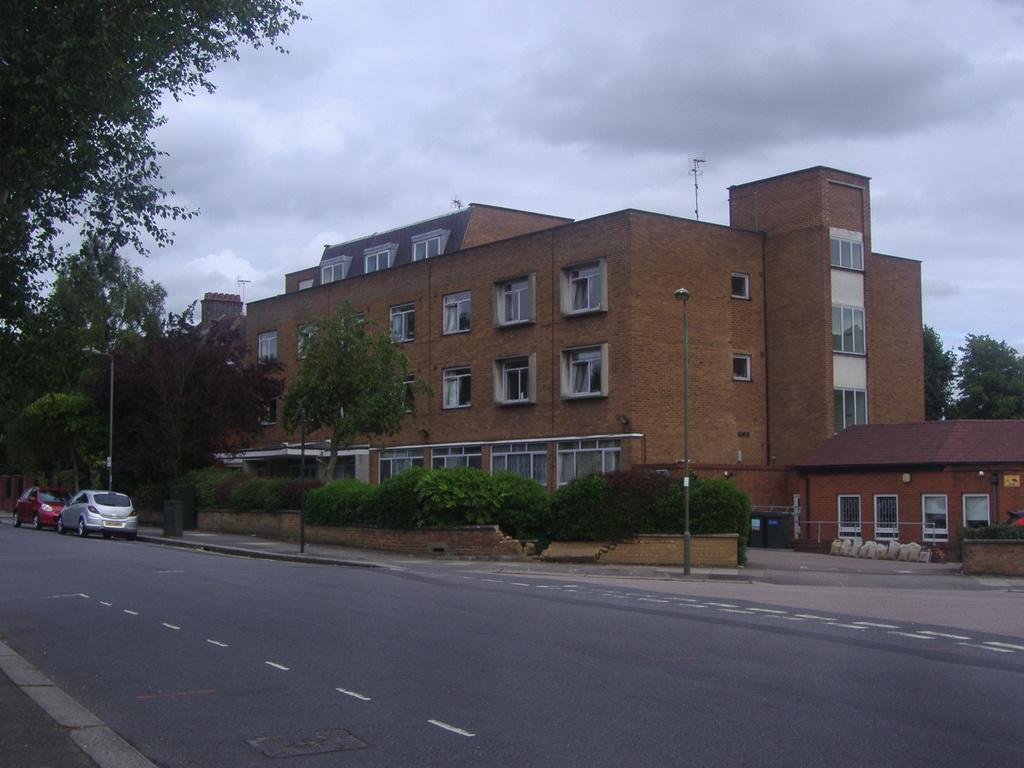Please provide a concise description of this image. In this image at the bottom there is a road, on the road there are some cars. In the center there are some buildings, trees, plants and in the background also there are some trees. On the top of the image there is sky. 